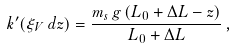<formula> <loc_0><loc_0><loc_500><loc_500>k ^ { \prime } ( \xi _ { V } \, d z ) = \frac { m _ { s } \, g \, ( L _ { 0 } + \Delta L - z ) } { L _ { 0 } + \Delta L } \, ,</formula> 